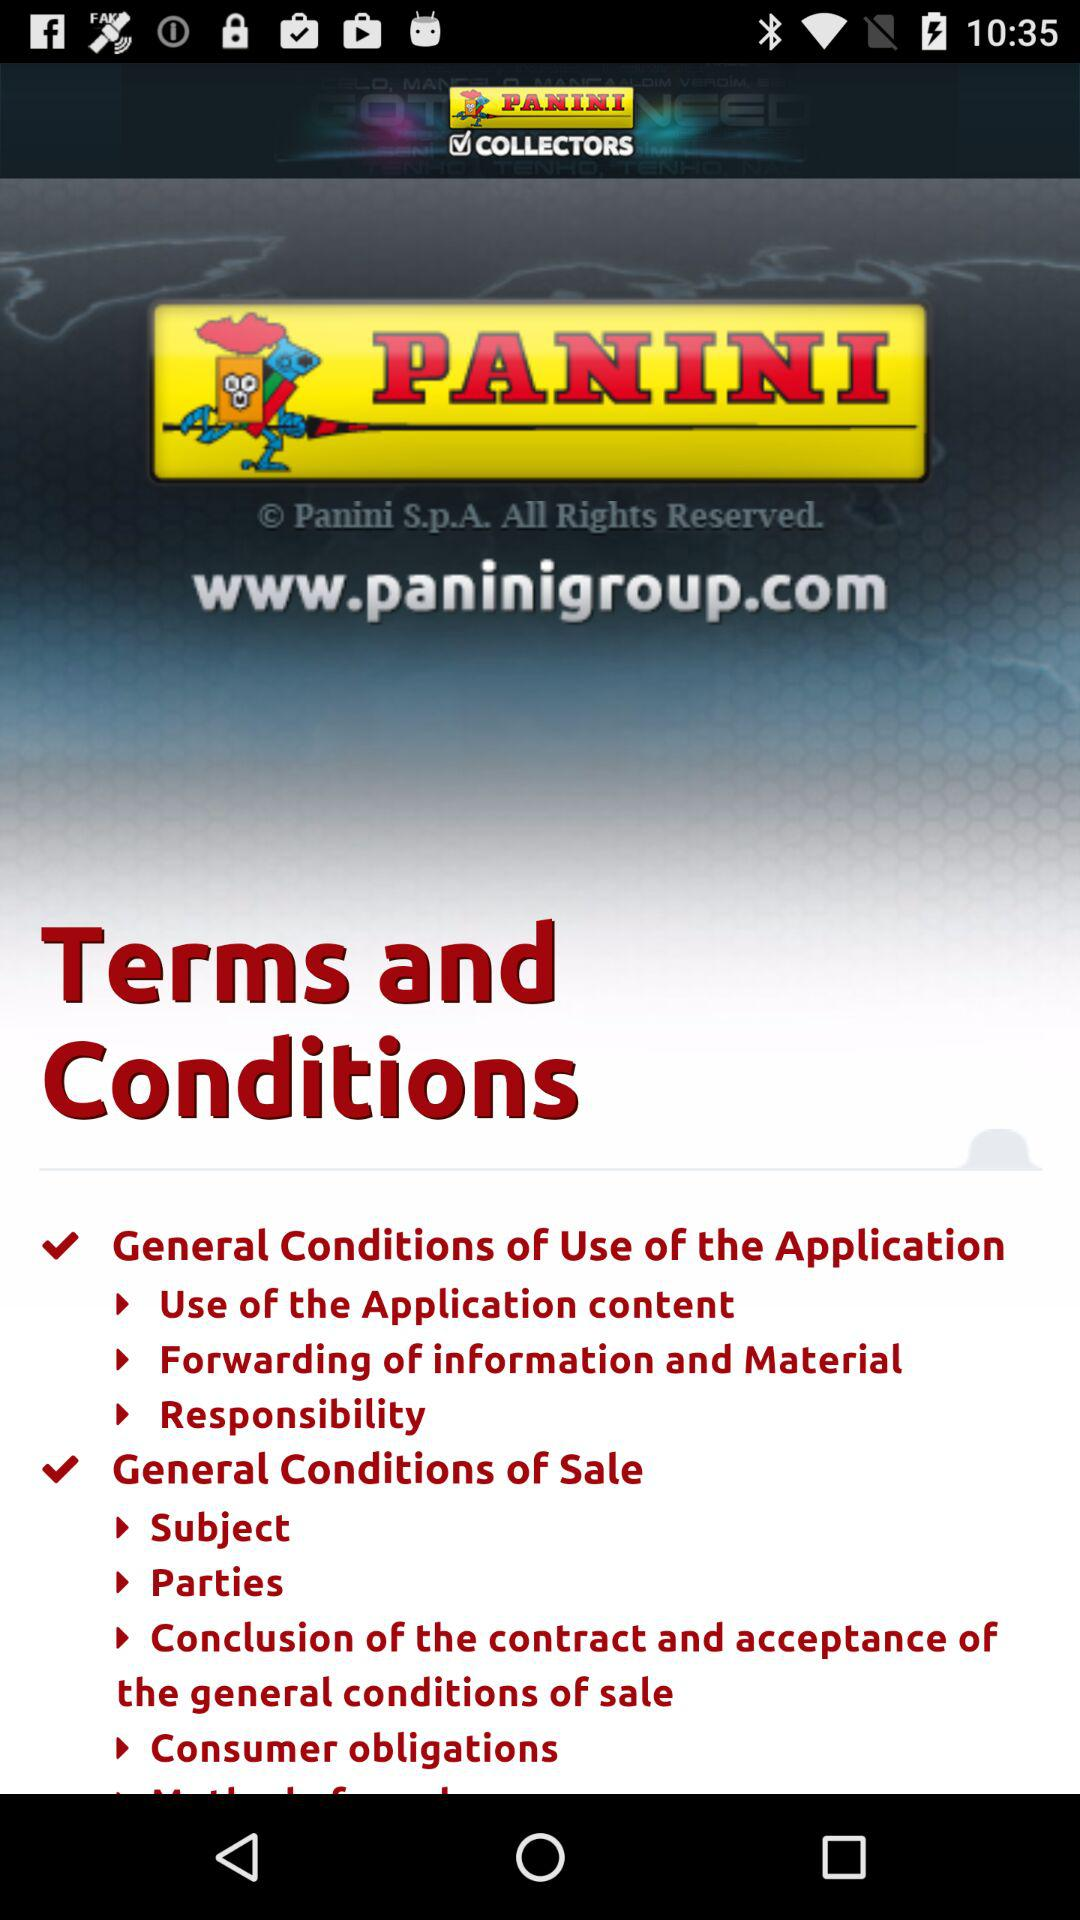What is the name of the application? The name of the application is "PANINI COLLECTORS". 